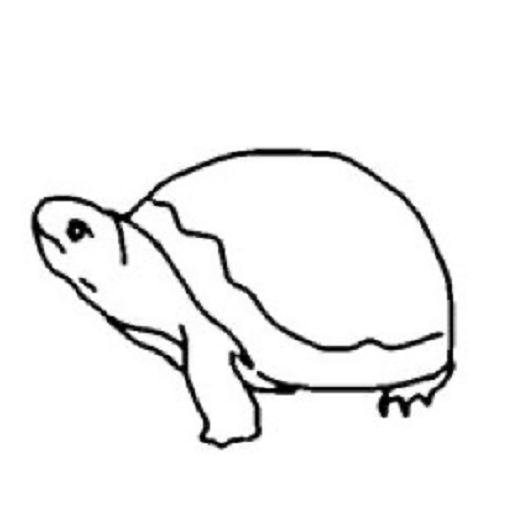Describe this drawing for a Stable Diffusion prompt A simple black line drawing of a turtle on a white background. The turtle is depicted in a minimalist style with smooth, curved lines forming the outline of its shell, head, legs and tail. The turtle's shell is a rounded oval shape, and its head is poking out from the front of the shell. The turtle's mouth is slightly open. The legs and tail are represented by simple curved strokes extending from the shell. The overall composition is centered in the frame with ample negative space around the turtle. 